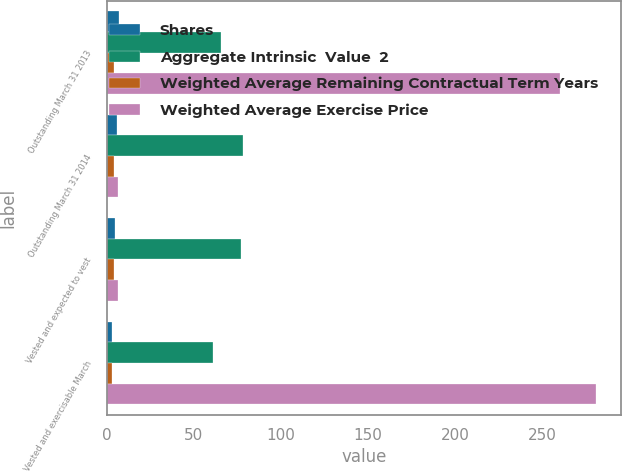<chart> <loc_0><loc_0><loc_500><loc_500><stacked_bar_chart><ecel><fcel>Outstanding March 31 2013<fcel>Outstanding March 31 2014<fcel>Vested and expected to vest<fcel>Vested and exercisable March<nl><fcel>Shares<fcel>7<fcel>6<fcel>5<fcel>3<nl><fcel>Aggregate Intrinsic  Value  2<fcel>65.79<fcel>78.07<fcel>77.27<fcel>61.07<nl><fcel>Weighted Average Remaining Contractual Term Years<fcel>4<fcel>4<fcel>4<fcel>3<nl><fcel>Weighted Average Exercise Price<fcel>260<fcel>6.5<fcel>6.5<fcel>281<nl></chart> 